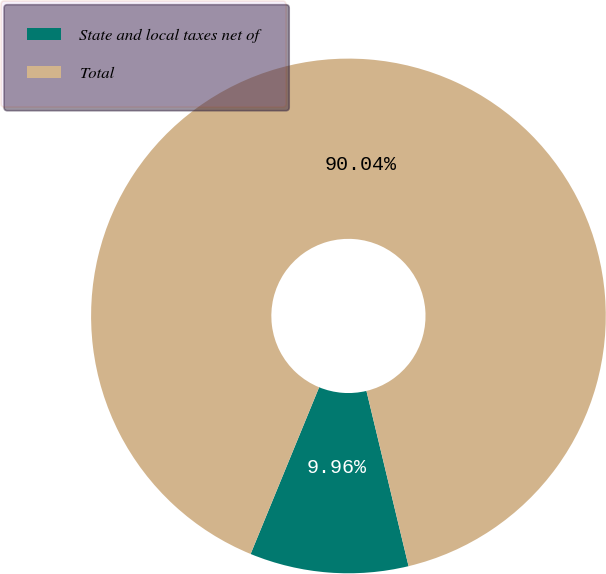Convert chart. <chart><loc_0><loc_0><loc_500><loc_500><pie_chart><fcel>State and local taxes net of<fcel>Total<nl><fcel>9.96%<fcel>90.04%<nl></chart> 